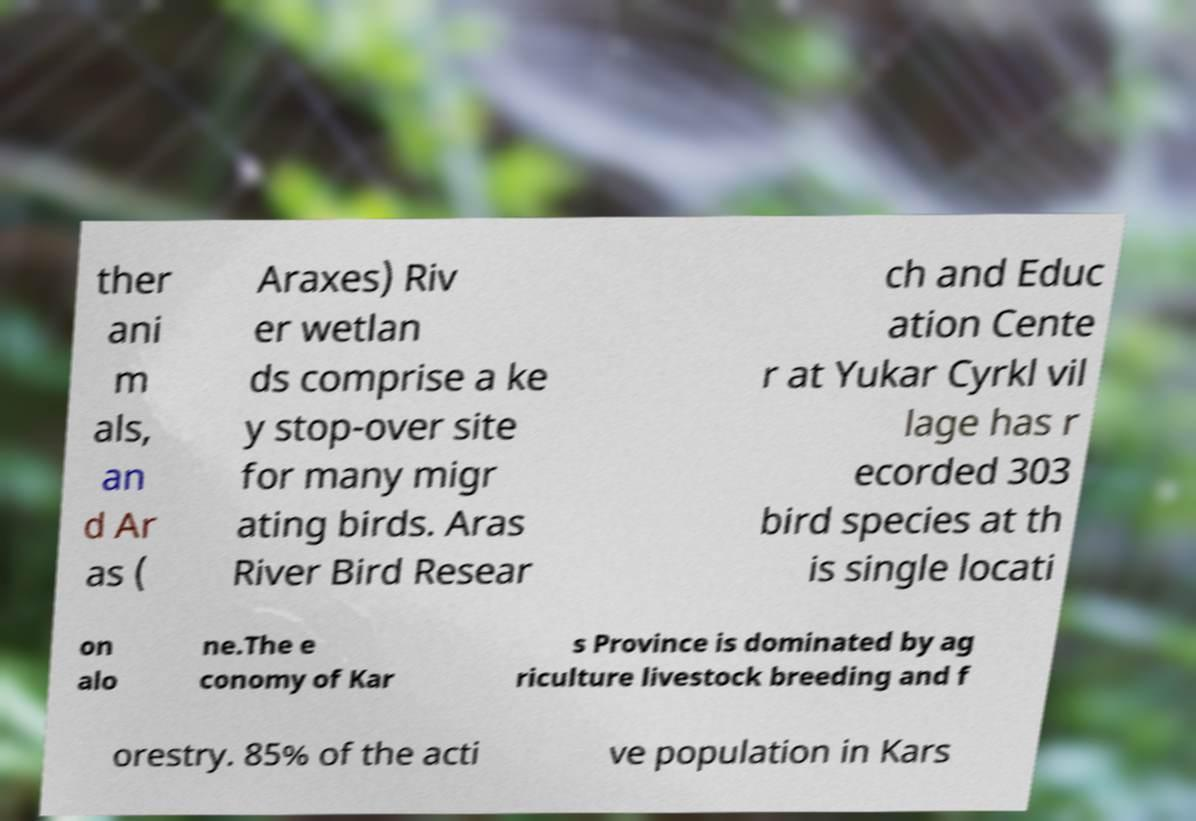Can you accurately transcribe the text from the provided image for me? ther ani m als, an d Ar as ( Araxes) Riv er wetlan ds comprise a ke y stop-over site for many migr ating birds. Aras River Bird Resear ch and Educ ation Cente r at Yukar Cyrkl vil lage has r ecorded 303 bird species at th is single locati on alo ne.The e conomy of Kar s Province is dominated by ag riculture livestock breeding and f orestry. 85% of the acti ve population in Kars 